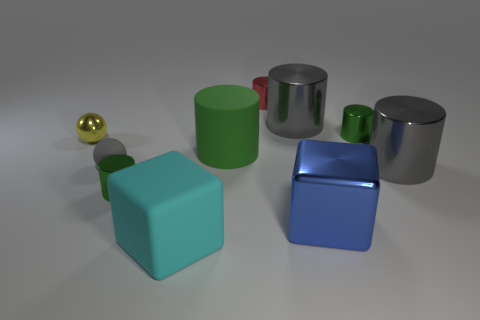Do the red thing and the gray matte sphere have the same size? The red cylinder and the gray matte sphere appear to be of different sizes. The red cylinder is taller but with a smaller diameter than the gray matte sphere, which looks almost perfectly round and slightly larger in volume. 